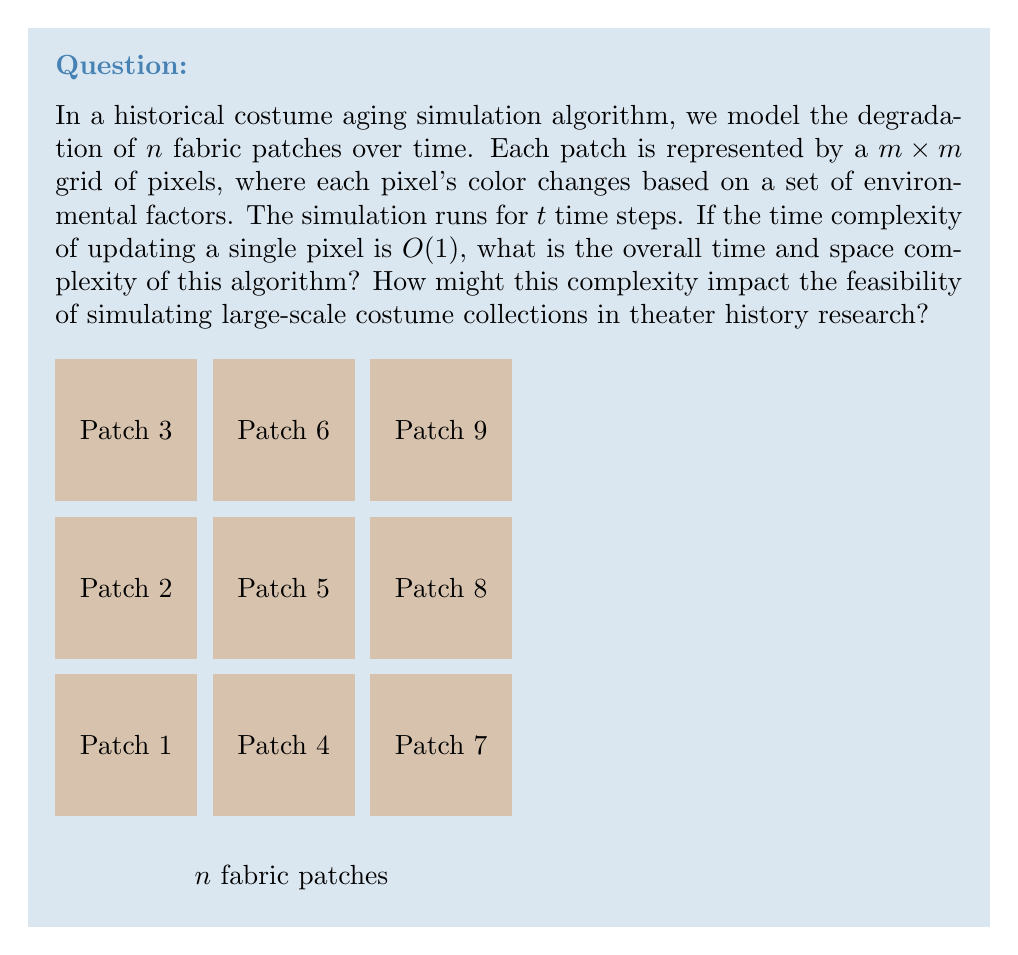What is the answer to this math problem? Let's break down the problem and analyze the complexity step by step:

1. We have $n$ fabric patches, each represented by an $m \times m$ grid of pixels.

2. The total number of pixels across all patches is $n \times m^2$.

3. For each time step, we need to update every pixel once.

4. The simulation runs for $t$ time steps.

5. Time complexity analysis:
   - Updating a single pixel: $O(1)$
   - Updating all pixels in one patch: $O(m^2)$
   - Updating all pixels in all patches: $O(n \times m^2)$
   - Doing this for $t$ time steps: $O(t \times n \times m^2)$

6. Space complexity analysis:
   - We need to store the state of each pixel: $O(n \times m^2)$
   - If we need to store the state at each time step (for review or rollback), it would be $O(t \times n \times m^2)$
   - If we only need the current state, it remains $O(n \times m^2)$

7. Impact on feasibility:
   - For large costume collections (large $n$) or highly detailed simulations (large $m$), the time complexity can become prohibitive.
   - The space complexity could limit the size of simulations that can be run on available hardware, especially if historical states need to be stored.
   - Researchers might need to balance between simulation accuracy (higher $m$ and $t$) and the ability to process large collections (higher $n$).
Answer: Time complexity: $O(t \times n \times m^2)$
Space complexity: $O(n \times m^2)$ (current state only) or $O(t \times n \times m^2)$ (all states) 